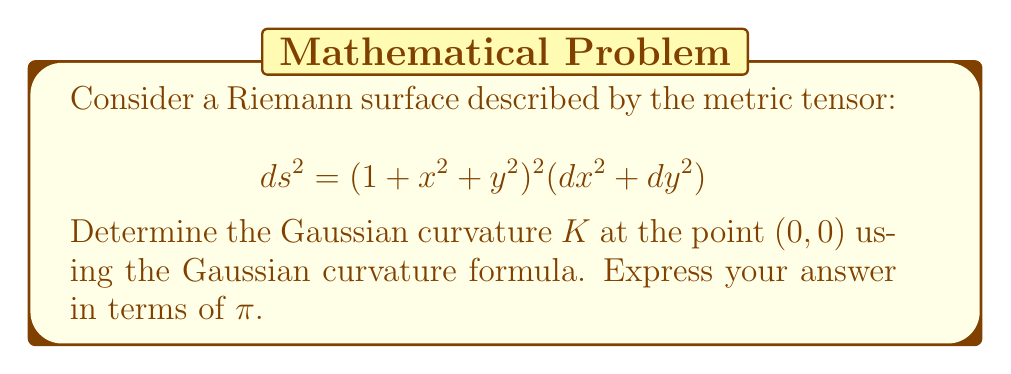Help me with this question. Let's approach this step-by-step:

1) The Gaussian curvature formula for a surface with metric $ds^2 = E(x,y)dx^2 + 2F(x,y)dxdy + G(x,y)dy^2$ is:

   $$K = -\frac{1}{2\sqrt{EG-F^2}}\left(\frac{\partial}{\partial x}\left(\frac{G_x}{\sqrt{EG-F^2}}\right) + \frac{\partial}{\partial y}\left(\frac{E_y}{\sqrt{EG-F^2}}\right)\right)$$

2) In our case, $E = G = (1 + x^2 + y^2)^2$ and $F = 0$. Let's call $h(x,y) = 1 + x^2 + y^2$ for simplicity.

3) We need to calculate:
   $E_x = G_x = 4h(x,y)h_x = 4h(x,y)(2x)$
   $E_y = G_y = 4h(x,y)h_y = 4h(x,y)(2y)$

4) Substituting into the formula:

   $$K = -\frac{1}{2h^2}\left(\frac{\partial}{\partial x}\left(\frac{4h(2x)}{h^2}\right) + \frac{\partial}{\partial y}\left(\frac{4h(2y)}{h^2}\right)\right)$$

5) Simplifying:

   $$K = -\frac{1}{2h^2}\left(\frac{\partial}{\partial x}\left(\frac{8x}{h}\right) + \frac{\partial}{\partial y}\left(\frac{8y}{h}\right)\right)$$

6) Applying the quotient rule:

   $$K = -\frac{1}{2h^2}\left(\frac{8h - 8x(2x)}{h^2} + \frac{8h - 8y(2y)}{h^2}\right)$$

7) Simplifying:

   $$K = -\frac{1}{2h^4}\left(8h - 16x^2 + 8h - 16y^2\right) = -\frac{8}{h^4}(2h - 2x^2 - 2y^2)$$

8) Substituting back $h = 1 + x^2 + y^2$:

   $$K = -\frac{8}{(1+x^2+y^2)^4}(2(1+x^2+y^2) - 2x^2 - 2y^2) = -\frac{16}{(1+x^2+y^2)^4}$$

9) At the point (0,0), this becomes:

   $$K_{(0,0)} = -16$$

10) To express this in terms of $\pi$, we can write:

    $$K_{(0,0)} = -\frac{16}{\pi}\pi = -\frac{16}{\pi}\pi$$
Answer: $-\frac{16}{\pi}\pi$ 